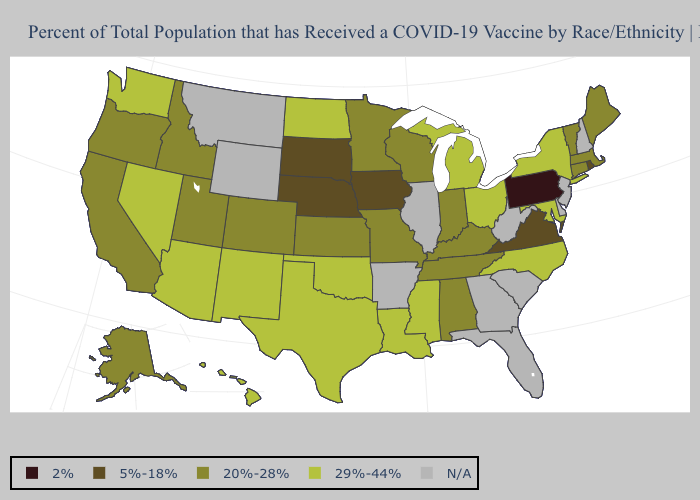Name the states that have a value in the range N/A?
Short answer required. Arkansas, Delaware, Florida, Georgia, Illinois, Montana, New Hampshire, New Jersey, South Carolina, West Virginia, Wyoming. Name the states that have a value in the range 5%-18%?
Write a very short answer. Iowa, Nebraska, Rhode Island, South Dakota, Virginia. Does Pennsylvania have the lowest value in the USA?
Give a very brief answer. Yes. What is the value of Missouri?
Give a very brief answer. 20%-28%. What is the lowest value in the USA?
Short answer required. 2%. What is the value of Louisiana?
Quick response, please. 29%-44%. Among the states that border South Carolina , which have the highest value?
Answer briefly. North Carolina. What is the highest value in states that border Utah?
Quick response, please. 29%-44%. Does New York have the highest value in the Northeast?
Write a very short answer. Yes. Does California have the lowest value in the West?
Short answer required. Yes. Which states have the lowest value in the Northeast?
Give a very brief answer. Pennsylvania. What is the highest value in the USA?
Concise answer only. 29%-44%. Does the map have missing data?
Quick response, please. Yes. Name the states that have a value in the range 2%?
Be succinct. Pennsylvania. Name the states that have a value in the range 20%-28%?
Short answer required. Alabama, Alaska, California, Colorado, Connecticut, Idaho, Indiana, Kansas, Kentucky, Maine, Massachusetts, Minnesota, Missouri, Oregon, Tennessee, Utah, Vermont, Wisconsin. 